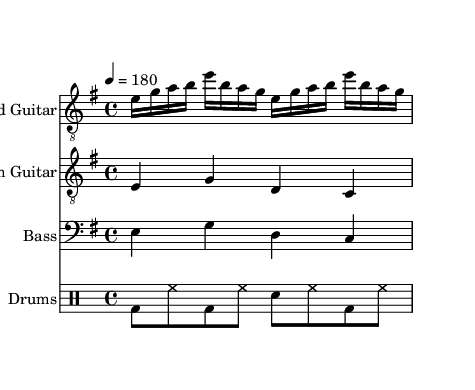What is the key signature of this music? The key signature is E minor, indicated by one sharp (F#) which is a characteristic of this scale.
Answer: E minor What is the time signature of the music? The time signature is 4/4, which means there are four beats in each measure and the quarter note gets one beat.
Answer: 4/4 What is the tempo of the piece? The tempo marking is 180 beats per minute, indicating how fast the piece should be played.
Answer: 180 How many measures are in the lead guitar part? The lead guitar part has 2 measures, as indicated by the repeat symbol that unfolds over that span.
Answer: 2 Which instrument plays the bass part? The instrument specified to play the bass part is the Bass Guitar, which is listed in the score under its respective staff.
Answer: Bass Guitar What type of music is represented here? The music type represented in the sheet is Thrash Metal, as indicated by the aggressive style of the composition and rhythmic patterns typical of the genre.
Answer: Thrash Metal What rhythmic pattern do the drums follow? The drumming pattern alternates between bass and hi-hat notes, featuring a strong kick on the first and third beats, characteristic of metal genres.
Answer: bd8 hh bd hh sn hh bd hh 